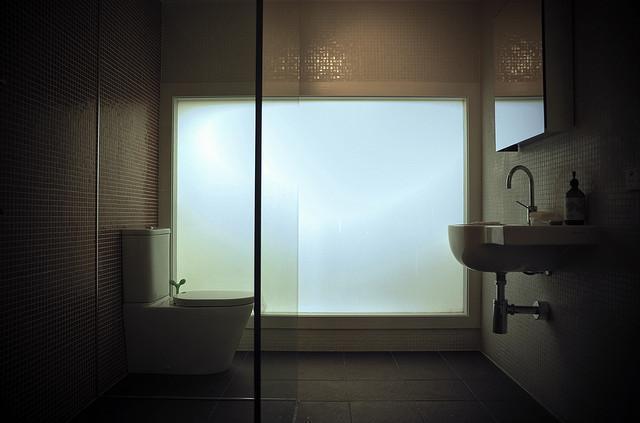How many pieces of bananas do you count?
Give a very brief answer. 0. 